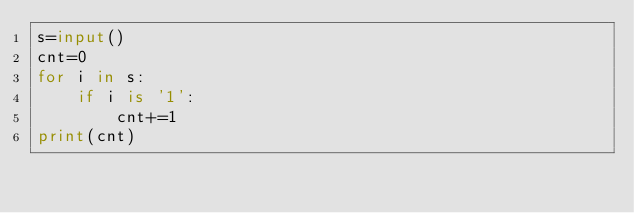Convert code to text. <code><loc_0><loc_0><loc_500><loc_500><_Python_>s=input()
cnt=0
for i in s:
    if i is '1':
        cnt+=1
print(cnt)
</code> 